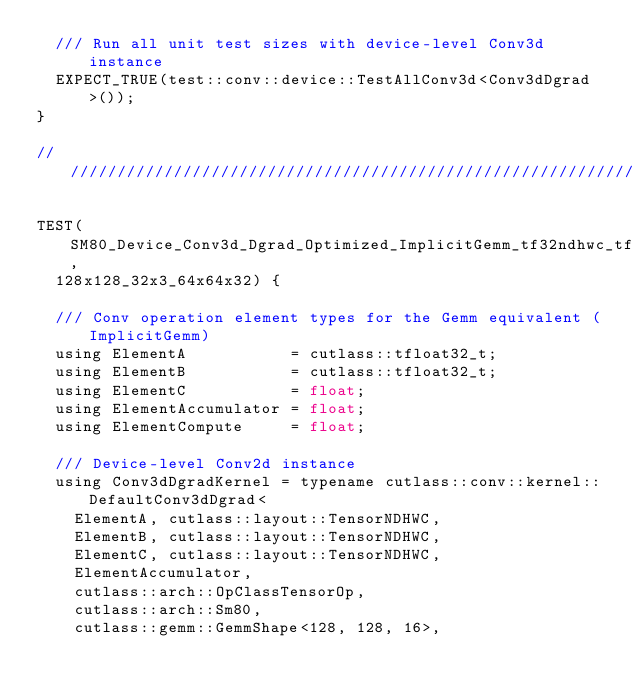<code> <loc_0><loc_0><loc_500><loc_500><_Cuda_>  /// Run all unit test sizes with device-level Conv3d instance
  EXPECT_TRUE(test::conv::device::TestAllConv3d<Conv3dDgrad>());
}

////////////////////////////////////////////////////////////////////////////////

TEST(SM80_Device_Conv3d_Dgrad_Optimized_ImplicitGemm_tf32ndhwc_tf32ndhwc_f32ndhwc_tensor_op_f32,
  128x128_32x3_64x64x32) {

  /// Conv operation element types for the Gemm equivalent (ImplicitGemm)
  using ElementA           = cutlass::tfloat32_t;
  using ElementB           = cutlass::tfloat32_t;
  using ElementC           = float;
  using ElementAccumulator = float;
  using ElementCompute     = float;

  /// Device-level Conv2d instance
  using Conv3dDgradKernel = typename cutlass::conv::kernel::DefaultConv3dDgrad<
    ElementA, cutlass::layout::TensorNDHWC,
    ElementB, cutlass::layout::TensorNDHWC,
    ElementC, cutlass::layout::TensorNDHWC,
    ElementAccumulator,
    cutlass::arch::OpClassTensorOp,
    cutlass::arch::Sm80,
    cutlass::gemm::GemmShape<128, 128, 16>,</code> 